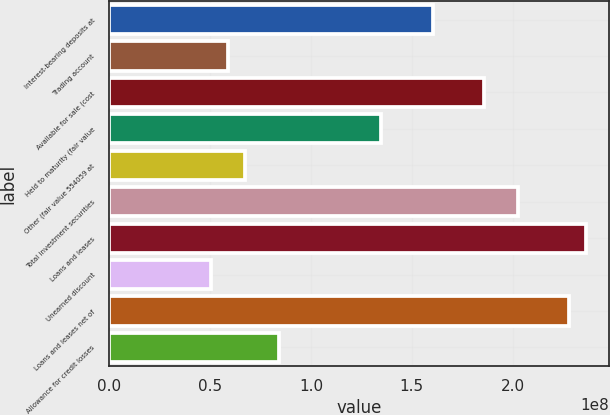Convert chart to OTSL. <chart><loc_0><loc_0><loc_500><loc_500><bar_chart><fcel>Interest-bearing deposits at<fcel>Trading account<fcel>Available for sale (cost<fcel>Held to maturity (fair value<fcel>Other (fair value 554059 at<fcel>Total investment securities<fcel>Loans and leases<fcel>Unearned discount<fcel>Loans and leases net of<fcel>Allowance for credit losses<nl><fcel>1.60262e+08<fcel>5.90455e+07<fcel>1.85566e+08<fcel>1.34958e+08<fcel>6.74802e+07<fcel>2.02435e+08<fcel>2.36174e+08<fcel>5.06108e+07<fcel>2.2774e+08<fcel>8.43496e+07<nl></chart> 